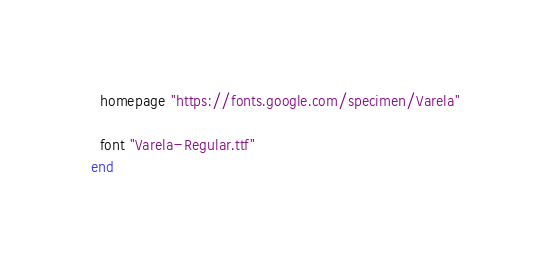<code> <loc_0><loc_0><loc_500><loc_500><_Ruby_>  homepage "https://fonts.google.com/specimen/Varela"

  font "Varela-Regular.ttf"
end
</code> 